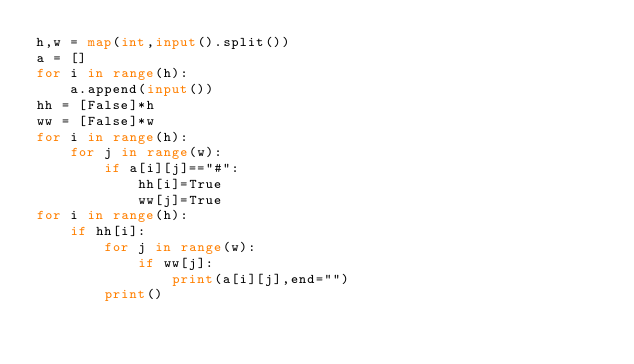<code> <loc_0><loc_0><loc_500><loc_500><_Python_>h,w = map(int,input().split())
a = []
for i in range(h):
    a.append(input())
hh = [False]*h
ww = [False]*w
for i in range(h):
    for j in range(w):
        if a[i][j]=="#":
            hh[i]=True
            ww[j]=True
for i in range(h):
    if hh[i]:
        for j in range(w):
            if ww[j]:
                print(a[i][j],end="")
        print()
</code> 